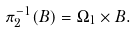<formula> <loc_0><loc_0><loc_500><loc_500>\pi _ { 2 } ^ { - 1 } ( B ) = \Omega _ { 1 } \times B .</formula> 